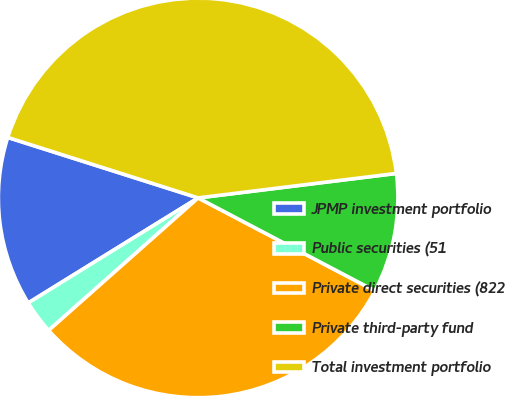<chart> <loc_0><loc_0><loc_500><loc_500><pie_chart><fcel>JPMP investment portfolio<fcel>Public securities (51<fcel>Private direct securities (822<fcel>Private third-party fund<fcel>Total investment portfolio<nl><fcel>13.71%<fcel>2.73%<fcel>30.76%<fcel>9.66%<fcel>43.15%<nl></chart> 